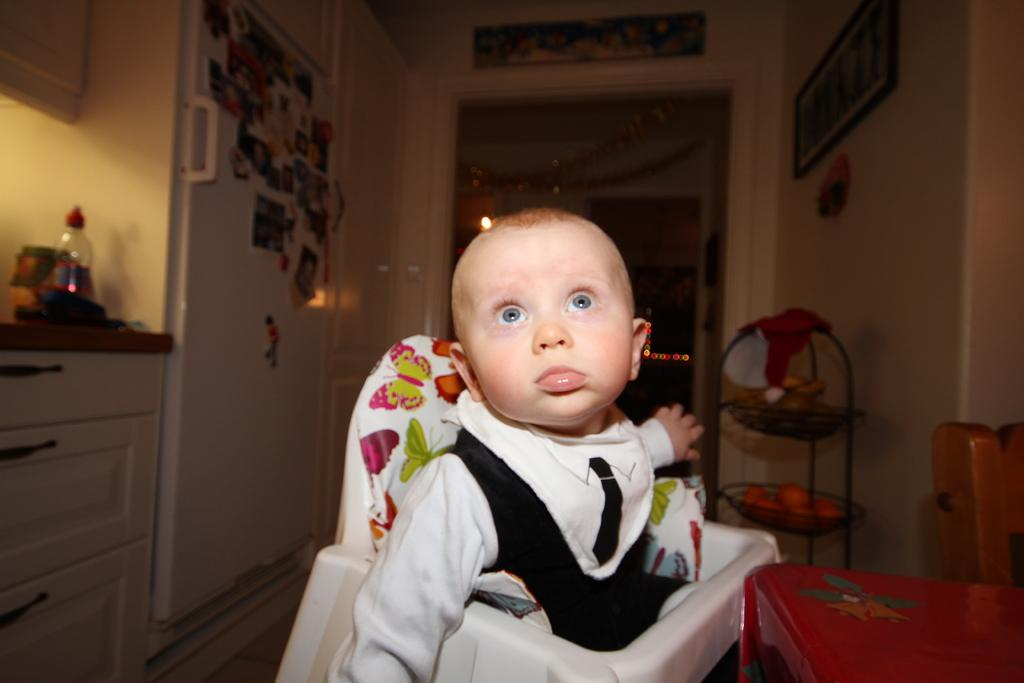What is the main subject of the image? There is a kid in the image. What can be seen in the background of the image? There is a door and a bottle in the background of the image. Are there any other objects visible in the background? Yes, there are some objects in the background of the image. Is the kid wearing a crown in the image? There is no crown visible in the image. What type of ornament is hanging from the door in the image? There is no ornament hanging from the door in the image. 